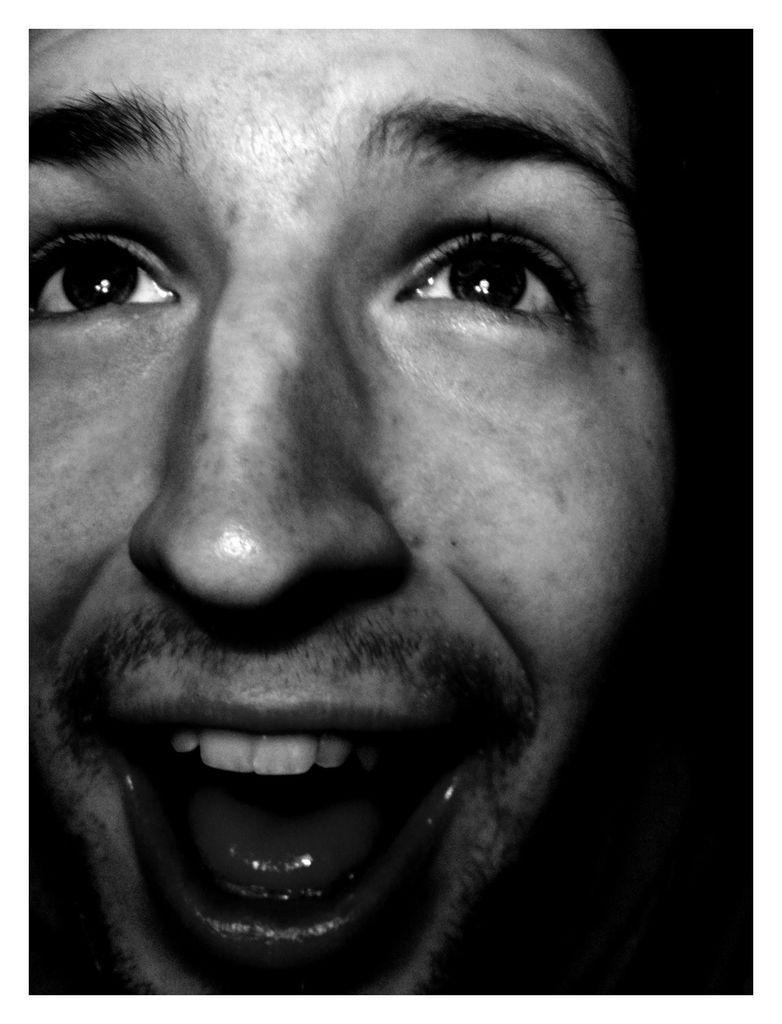How would you summarize this image in a sentence or two? The picture consists of a man smiling. On the right it is dark. 